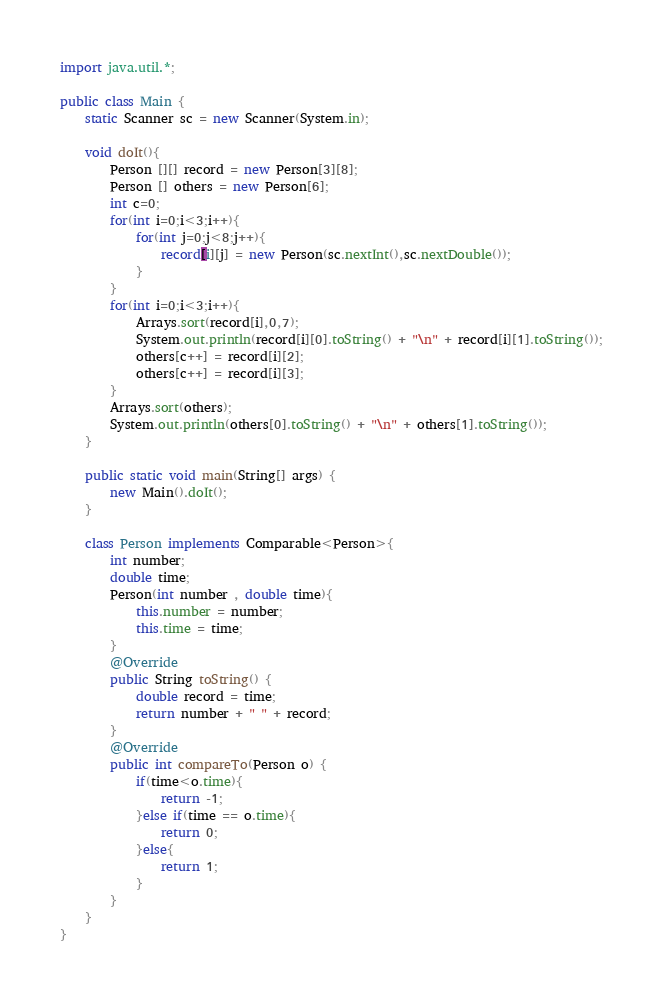Convert code to text. <code><loc_0><loc_0><loc_500><loc_500><_Java_>import java.util.*;

public class Main {
	static Scanner sc = new Scanner(System.in);
	
	void doIt(){
		Person [][] record = new Person[3][8];
		Person [] others = new Person[6];
		int c=0;
		for(int i=0;i<3;i++){
			for(int j=0;j<8;j++){
				record[i][j] = new Person(sc.nextInt(),sc.nextDouble());
			}
		}
		for(int i=0;i<3;i++){
			Arrays.sort(record[i],0,7);
			System.out.println(record[i][0].toString() + "\n" + record[i][1].toString());
			others[c++] = record[i][2];
			others[c++] = record[i][3];
		}
		Arrays.sort(others);
		System.out.println(others[0].toString() + "\n" + others[1].toString());		
	}

	public static void main(String[] args) {
		new Main().doIt();
	}
	
	class Person implements Comparable<Person>{
		int number;
		double time;
		Person(int number , double time){
			this.number = number;
			this.time = time;
		}
		@Override
		public String toString() {
			double record = time;
			return number + " " + record;
		}
		@Override
		public int compareTo(Person o) {
			if(time<o.time){
				return -1;
			}else if(time == o.time){
				return 0;
			}else{
				return 1;				
			}
		}
	}
}</code> 